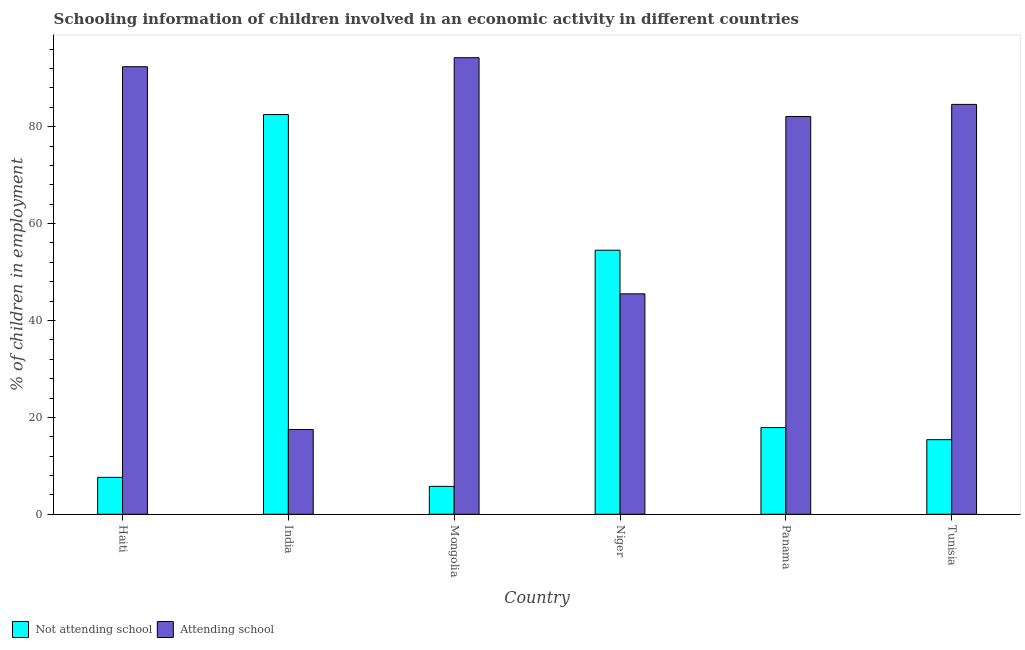How many different coloured bars are there?
Give a very brief answer. 2. Are the number of bars per tick equal to the number of legend labels?
Give a very brief answer. Yes. How many bars are there on the 6th tick from the left?
Provide a short and direct response. 2. How many bars are there on the 6th tick from the right?
Offer a very short reply. 2. What is the label of the 6th group of bars from the left?
Give a very brief answer. Tunisia. What is the percentage of employed children who are not attending school in Mongolia?
Ensure brevity in your answer.  5.76. Across all countries, what is the maximum percentage of employed children who are not attending school?
Provide a succinct answer. 82.5. In which country was the percentage of employed children who are attending school maximum?
Offer a very short reply. Mongolia. In which country was the percentage of employed children who are not attending school minimum?
Your answer should be very brief. Mongolia. What is the total percentage of employed children who are attending school in the graph?
Offer a very short reply. 416.32. What is the difference between the percentage of employed children who are not attending school in Panama and that in Tunisia?
Your answer should be compact. 2.5. What is the difference between the percentage of employed children who are attending school in Tunisia and the percentage of employed children who are not attending school in Panama?
Give a very brief answer. 66.7. What is the average percentage of employed children who are attending school per country?
Provide a succinct answer. 69.39. What is the difference between the percentage of employed children who are not attending school and percentage of employed children who are attending school in Niger?
Offer a terse response. 9. In how many countries, is the percentage of employed children who are attending school greater than 72 %?
Your answer should be compact. 4. What is the ratio of the percentage of employed children who are attending school in India to that in Tunisia?
Make the answer very short. 0.21. What is the difference between the highest and the lowest percentage of employed children who are attending school?
Make the answer very short. 76.74. Is the sum of the percentage of employed children who are not attending school in Haiti and India greater than the maximum percentage of employed children who are attending school across all countries?
Your response must be concise. No. What does the 1st bar from the left in Mongolia represents?
Your response must be concise. Not attending school. What does the 1st bar from the right in Niger represents?
Provide a short and direct response. Attending school. How many bars are there?
Your answer should be very brief. 12. How many countries are there in the graph?
Ensure brevity in your answer.  6. What is the difference between two consecutive major ticks on the Y-axis?
Keep it short and to the point. 20. Does the graph contain grids?
Keep it short and to the point. No. How many legend labels are there?
Offer a terse response. 2. How are the legend labels stacked?
Make the answer very short. Horizontal. What is the title of the graph?
Offer a very short reply. Schooling information of children involved in an economic activity in different countries. Does "Official creditors" appear as one of the legend labels in the graph?
Offer a terse response. No. What is the label or title of the X-axis?
Offer a terse response. Country. What is the label or title of the Y-axis?
Give a very brief answer. % of children in employment. What is the % of children in employment of Not attending school in Haiti?
Ensure brevity in your answer.  7.62. What is the % of children in employment of Attending school in Haiti?
Ensure brevity in your answer.  92.38. What is the % of children in employment of Not attending school in India?
Your response must be concise. 82.5. What is the % of children in employment in Not attending school in Mongolia?
Your answer should be compact. 5.76. What is the % of children in employment of Attending school in Mongolia?
Make the answer very short. 94.24. What is the % of children in employment of Not attending school in Niger?
Make the answer very short. 54.5. What is the % of children in employment of Attending school in Niger?
Ensure brevity in your answer.  45.5. What is the % of children in employment in Attending school in Panama?
Give a very brief answer. 82.1. What is the % of children in employment of Not attending school in Tunisia?
Provide a succinct answer. 15.4. What is the % of children in employment in Attending school in Tunisia?
Your response must be concise. 84.6. Across all countries, what is the maximum % of children in employment in Not attending school?
Offer a terse response. 82.5. Across all countries, what is the maximum % of children in employment in Attending school?
Your answer should be very brief. 94.24. Across all countries, what is the minimum % of children in employment in Not attending school?
Your answer should be very brief. 5.76. Across all countries, what is the minimum % of children in employment of Attending school?
Make the answer very short. 17.5. What is the total % of children in employment of Not attending school in the graph?
Make the answer very short. 183.68. What is the total % of children in employment in Attending school in the graph?
Give a very brief answer. 416.32. What is the difference between the % of children in employment of Not attending school in Haiti and that in India?
Provide a short and direct response. -74.88. What is the difference between the % of children in employment of Attending school in Haiti and that in India?
Ensure brevity in your answer.  74.88. What is the difference between the % of children in employment in Not attending school in Haiti and that in Mongolia?
Give a very brief answer. 1.86. What is the difference between the % of children in employment of Attending school in Haiti and that in Mongolia?
Your response must be concise. -1.86. What is the difference between the % of children in employment of Not attending school in Haiti and that in Niger?
Ensure brevity in your answer.  -46.88. What is the difference between the % of children in employment in Attending school in Haiti and that in Niger?
Give a very brief answer. 46.88. What is the difference between the % of children in employment in Not attending school in Haiti and that in Panama?
Provide a short and direct response. -10.28. What is the difference between the % of children in employment of Attending school in Haiti and that in Panama?
Your response must be concise. 10.28. What is the difference between the % of children in employment in Not attending school in Haiti and that in Tunisia?
Keep it short and to the point. -7.78. What is the difference between the % of children in employment of Attending school in Haiti and that in Tunisia?
Keep it short and to the point. 7.78. What is the difference between the % of children in employment of Not attending school in India and that in Mongolia?
Your answer should be very brief. 76.74. What is the difference between the % of children in employment in Attending school in India and that in Mongolia?
Provide a succinct answer. -76.74. What is the difference between the % of children in employment in Not attending school in India and that in Niger?
Offer a very short reply. 28. What is the difference between the % of children in employment in Not attending school in India and that in Panama?
Keep it short and to the point. 64.6. What is the difference between the % of children in employment in Attending school in India and that in Panama?
Provide a succinct answer. -64.6. What is the difference between the % of children in employment in Not attending school in India and that in Tunisia?
Provide a short and direct response. 67.1. What is the difference between the % of children in employment of Attending school in India and that in Tunisia?
Provide a succinct answer. -67.1. What is the difference between the % of children in employment of Not attending school in Mongolia and that in Niger?
Ensure brevity in your answer.  -48.74. What is the difference between the % of children in employment of Attending school in Mongolia and that in Niger?
Your response must be concise. 48.74. What is the difference between the % of children in employment in Not attending school in Mongolia and that in Panama?
Provide a succinct answer. -12.14. What is the difference between the % of children in employment of Attending school in Mongolia and that in Panama?
Keep it short and to the point. 12.14. What is the difference between the % of children in employment of Not attending school in Mongolia and that in Tunisia?
Your answer should be compact. -9.64. What is the difference between the % of children in employment in Attending school in Mongolia and that in Tunisia?
Your answer should be compact. 9.64. What is the difference between the % of children in employment of Not attending school in Niger and that in Panama?
Make the answer very short. 36.6. What is the difference between the % of children in employment in Attending school in Niger and that in Panama?
Provide a short and direct response. -36.6. What is the difference between the % of children in employment in Not attending school in Niger and that in Tunisia?
Offer a very short reply. 39.1. What is the difference between the % of children in employment in Attending school in Niger and that in Tunisia?
Offer a very short reply. -39.1. What is the difference between the % of children in employment of Attending school in Panama and that in Tunisia?
Provide a succinct answer. -2.5. What is the difference between the % of children in employment of Not attending school in Haiti and the % of children in employment of Attending school in India?
Your answer should be compact. -9.88. What is the difference between the % of children in employment in Not attending school in Haiti and the % of children in employment in Attending school in Mongolia?
Make the answer very short. -86.62. What is the difference between the % of children in employment in Not attending school in Haiti and the % of children in employment in Attending school in Niger?
Your response must be concise. -37.88. What is the difference between the % of children in employment in Not attending school in Haiti and the % of children in employment in Attending school in Panama?
Your answer should be very brief. -74.48. What is the difference between the % of children in employment of Not attending school in Haiti and the % of children in employment of Attending school in Tunisia?
Offer a very short reply. -76.98. What is the difference between the % of children in employment in Not attending school in India and the % of children in employment in Attending school in Mongolia?
Provide a short and direct response. -11.74. What is the difference between the % of children in employment in Not attending school in India and the % of children in employment in Attending school in Panama?
Offer a terse response. 0.4. What is the difference between the % of children in employment of Not attending school in India and the % of children in employment of Attending school in Tunisia?
Offer a very short reply. -2.1. What is the difference between the % of children in employment in Not attending school in Mongolia and the % of children in employment in Attending school in Niger?
Provide a succinct answer. -39.74. What is the difference between the % of children in employment of Not attending school in Mongolia and the % of children in employment of Attending school in Panama?
Give a very brief answer. -76.34. What is the difference between the % of children in employment of Not attending school in Mongolia and the % of children in employment of Attending school in Tunisia?
Provide a succinct answer. -78.84. What is the difference between the % of children in employment of Not attending school in Niger and the % of children in employment of Attending school in Panama?
Your answer should be compact. -27.6. What is the difference between the % of children in employment in Not attending school in Niger and the % of children in employment in Attending school in Tunisia?
Your answer should be very brief. -30.1. What is the difference between the % of children in employment in Not attending school in Panama and the % of children in employment in Attending school in Tunisia?
Ensure brevity in your answer.  -66.7. What is the average % of children in employment in Not attending school per country?
Provide a short and direct response. 30.61. What is the average % of children in employment of Attending school per country?
Keep it short and to the point. 69.39. What is the difference between the % of children in employment in Not attending school and % of children in employment in Attending school in Haiti?
Ensure brevity in your answer.  -84.76. What is the difference between the % of children in employment of Not attending school and % of children in employment of Attending school in Mongolia?
Your answer should be very brief. -88.48. What is the difference between the % of children in employment in Not attending school and % of children in employment in Attending school in Panama?
Offer a very short reply. -64.2. What is the difference between the % of children in employment in Not attending school and % of children in employment in Attending school in Tunisia?
Make the answer very short. -69.2. What is the ratio of the % of children in employment in Not attending school in Haiti to that in India?
Your answer should be compact. 0.09. What is the ratio of the % of children in employment of Attending school in Haiti to that in India?
Offer a very short reply. 5.28. What is the ratio of the % of children in employment in Not attending school in Haiti to that in Mongolia?
Your answer should be compact. 1.32. What is the ratio of the % of children in employment of Attending school in Haiti to that in Mongolia?
Ensure brevity in your answer.  0.98. What is the ratio of the % of children in employment in Not attending school in Haiti to that in Niger?
Keep it short and to the point. 0.14. What is the ratio of the % of children in employment in Attending school in Haiti to that in Niger?
Give a very brief answer. 2.03. What is the ratio of the % of children in employment in Not attending school in Haiti to that in Panama?
Offer a terse response. 0.43. What is the ratio of the % of children in employment in Attending school in Haiti to that in Panama?
Offer a terse response. 1.13. What is the ratio of the % of children in employment of Not attending school in Haiti to that in Tunisia?
Ensure brevity in your answer.  0.49. What is the ratio of the % of children in employment of Attending school in Haiti to that in Tunisia?
Provide a succinct answer. 1.09. What is the ratio of the % of children in employment of Not attending school in India to that in Mongolia?
Provide a short and direct response. 14.32. What is the ratio of the % of children in employment of Attending school in India to that in Mongolia?
Your answer should be compact. 0.19. What is the ratio of the % of children in employment of Not attending school in India to that in Niger?
Keep it short and to the point. 1.51. What is the ratio of the % of children in employment of Attending school in India to that in Niger?
Offer a terse response. 0.38. What is the ratio of the % of children in employment in Not attending school in India to that in Panama?
Offer a very short reply. 4.61. What is the ratio of the % of children in employment of Attending school in India to that in Panama?
Your answer should be very brief. 0.21. What is the ratio of the % of children in employment of Not attending school in India to that in Tunisia?
Your response must be concise. 5.36. What is the ratio of the % of children in employment of Attending school in India to that in Tunisia?
Give a very brief answer. 0.21. What is the ratio of the % of children in employment of Not attending school in Mongolia to that in Niger?
Keep it short and to the point. 0.11. What is the ratio of the % of children in employment in Attending school in Mongolia to that in Niger?
Provide a short and direct response. 2.07. What is the ratio of the % of children in employment in Not attending school in Mongolia to that in Panama?
Offer a terse response. 0.32. What is the ratio of the % of children in employment of Attending school in Mongolia to that in Panama?
Your response must be concise. 1.15. What is the ratio of the % of children in employment of Not attending school in Mongolia to that in Tunisia?
Offer a very short reply. 0.37. What is the ratio of the % of children in employment of Attending school in Mongolia to that in Tunisia?
Offer a very short reply. 1.11. What is the ratio of the % of children in employment in Not attending school in Niger to that in Panama?
Offer a very short reply. 3.04. What is the ratio of the % of children in employment of Attending school in Niger to that in Panama?
Provide a succinct answer. 0.55. What is the ratio of the % of children in employment in Not attending school in Niger to that in Tunisia?
Offer a terse response. 3.54. What is the ratio of the % of children in employment of Attending school in Niger to that in Tunisia?
Ensure brevity in your answer.  0.54. What is the ratio of the % of children in employment in Not attending school in Panama to that in Tunisia?
Keep it short and to the point. 1.16. What is the ratio of the % of children in employment of Attending school in Panama to that in Tunisia?
Offer a very short reply. 0.97. What is the difference between the highest and the second highest % of children in employment in Not attending school?
Give a very brief answer. 28. What is the difference between the highest and the second highest % of children in employment of Attending school?
Provide a short and direct response. 1.86. What is the difference between the highest and the lowest % of children in employment in Not attending school?
Provide a succinct answer. 76.74. What is the difference between the highest and the lowest % of children in employment of Attending school?
Your answer should be very brief. 76.74. 